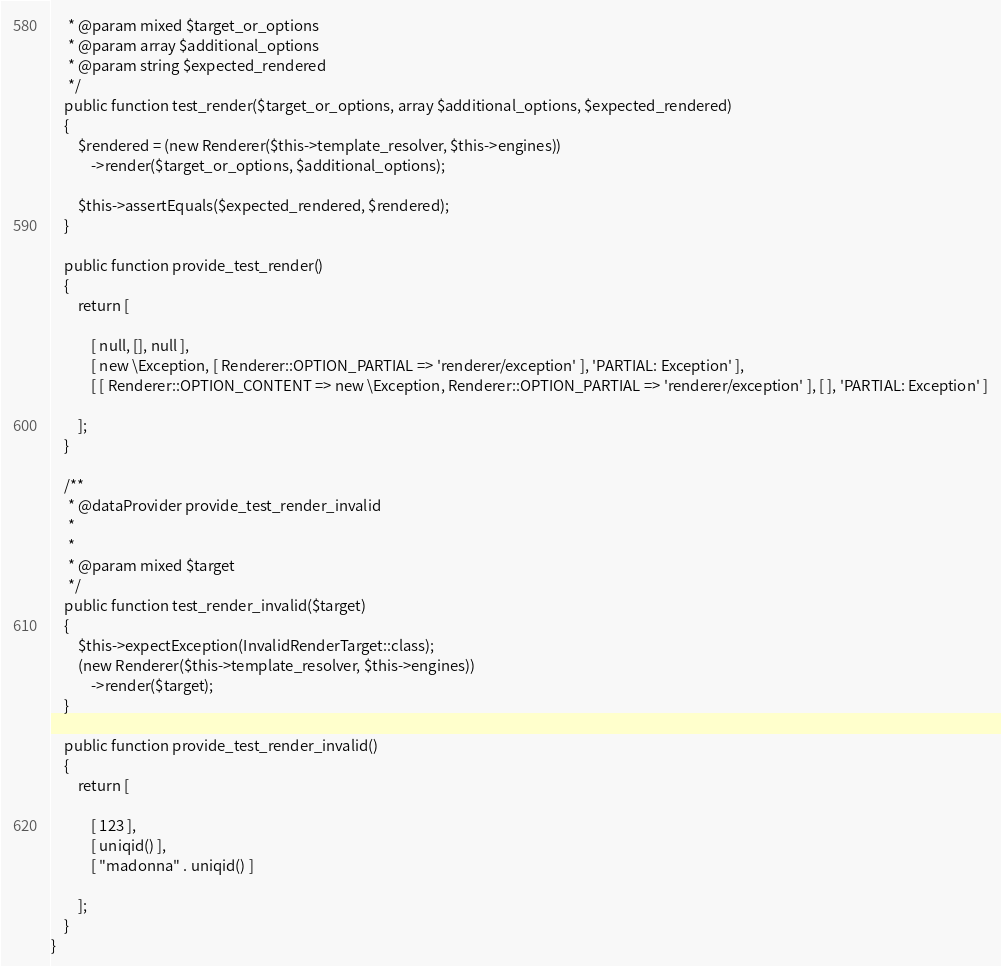Convert code to text. <code><loc_0><loc_0><loc_500><loc_500><_PHP_>	 * @param mixed $target_or_options
	 * @param array $additional_options
	 * @param string $expected_rendered
	 */
	public function test_render($target_or_options, array $additional_options, $expected_rendered)
	{
		$rendered = (new Renderer($this->template_resolver, $this->engines))
			->render($target_or_options, $additional_options);

		$this->assertEquals($expected_rendered, $rendered);
	}

	public function provide_test_render()
	{
		return [

			[ null, [], null ],
			[ new \Exception, [ Renderer::OPTION_PARTIAL => 'renderer/exception' ], 'PARTIAL: Exception' ],
			[ [ Renderer::OPTION_CONTENT => new \Exception, Renderer::OPTION_PARTIAL => 'renderer/exception' ], [ ], 'PARTIAL: Exception' ]

		];
	}

	/**
	 * @dataProvider provide_test_render_invalid
	 *
	 *
	 * @param mixed $target
	 */
	public function test_render_invalid($target)
	{
		$this->expectException(InvalidRenderTarget::class);
		(new Renderer($this->template_resolver, $this->engines))
			->render($target);
	}

	public function provide_test_render_invalid()
	{
		return [

			[ 123 ],
			[ uniqid() ],
			[ "madonna" . uniqid() ]

		];
	}
}
</code> 